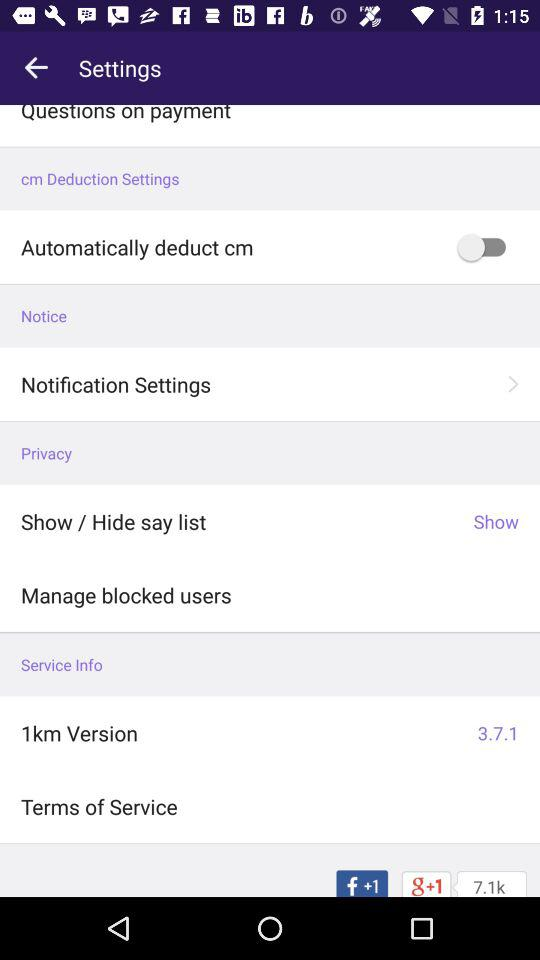What is the version of "1km"? The version of the '1km' app, as displayed in your mobile settings under service info, is 3.7.1. It is always good to keep your apps updated for improved features and security. 